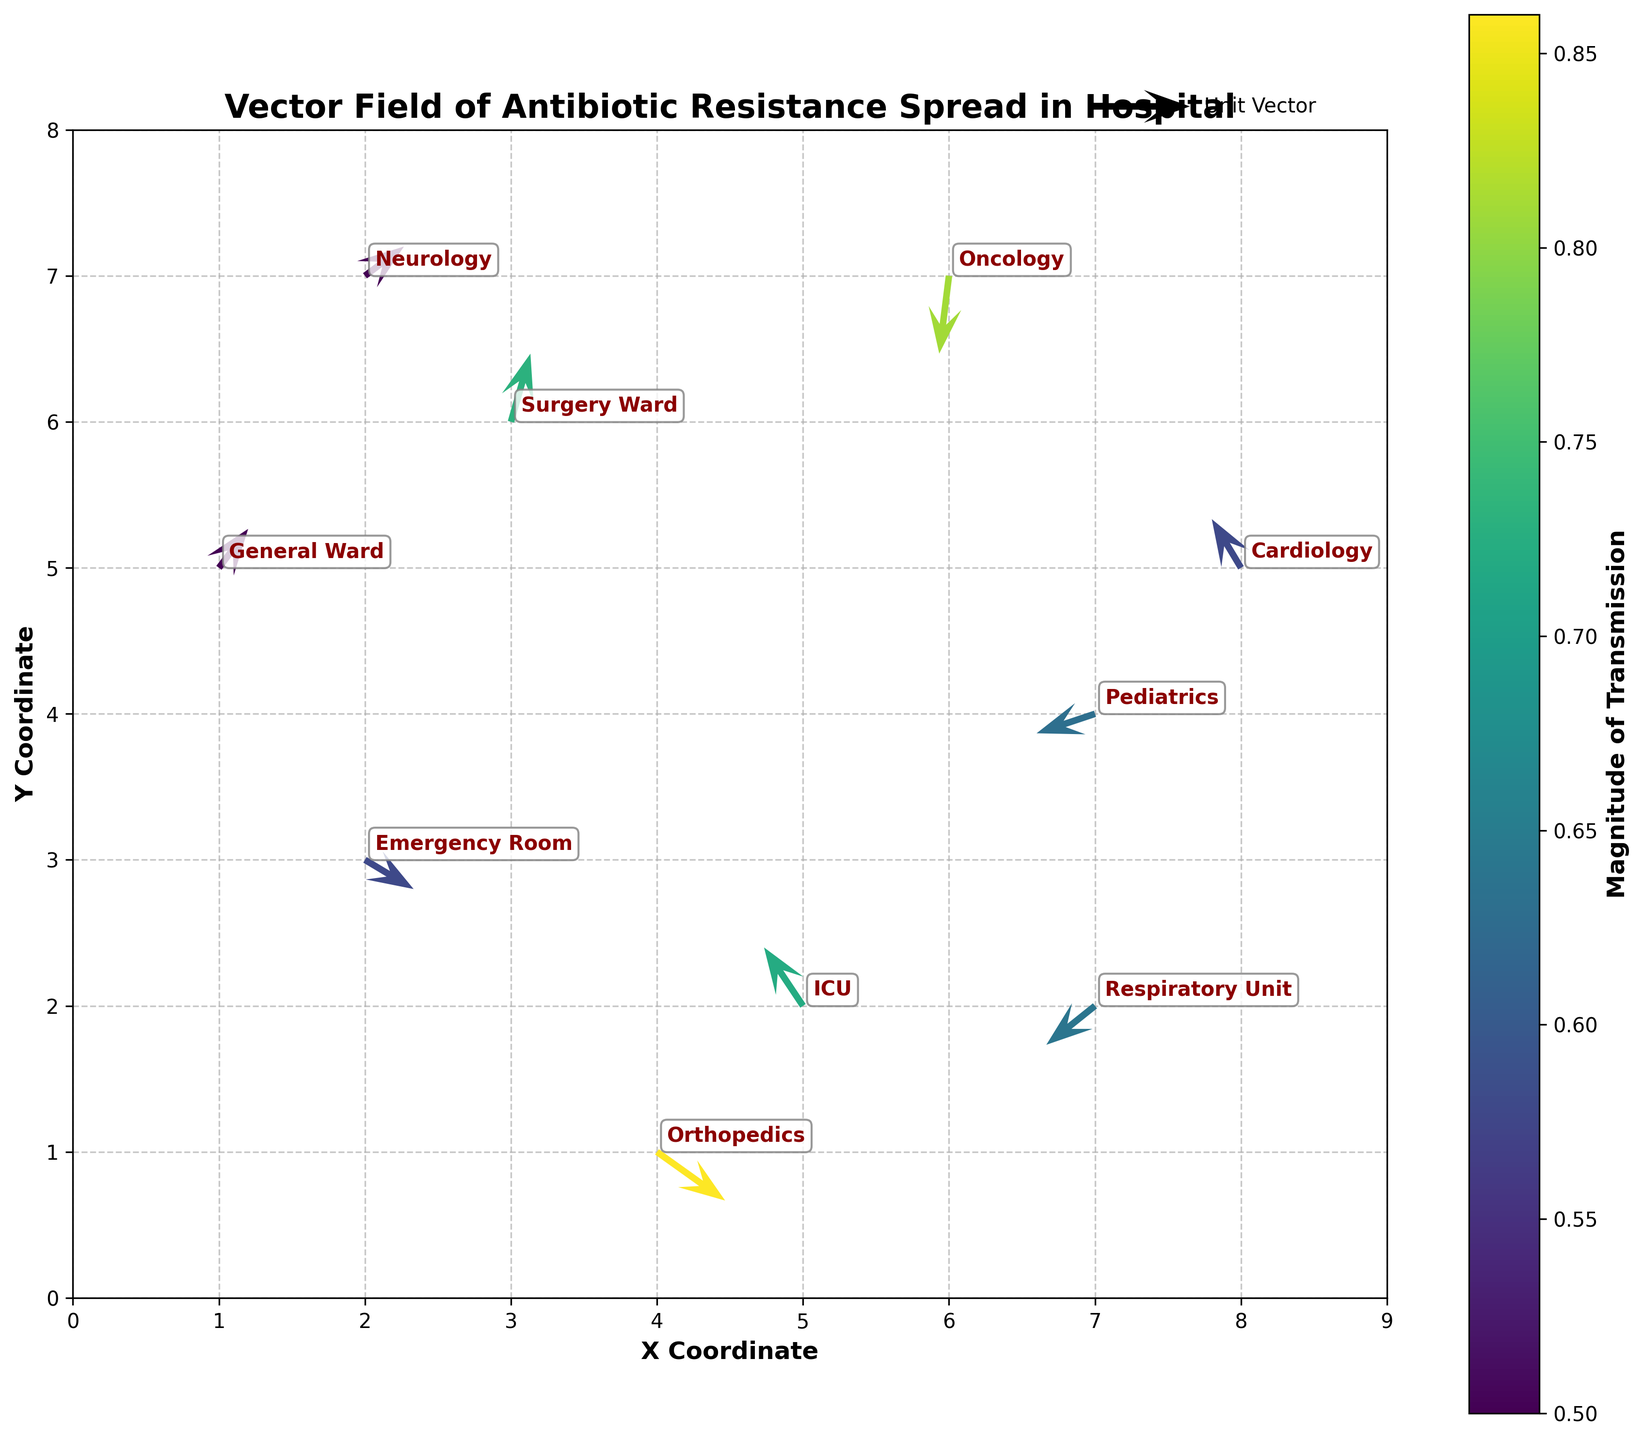What is the title of the figure? The title is usually displayed at the top of the figure. In this case, the title is "Vector Field of Antibiotic Resistance Spread in Hospital."
Answer: Vector Field of Antibiotic Resistance Spread in Hospital How many data points are represented in the figure? We can count the number of arrows or vectors in the quiver plot. Each arrow represents a data point. In this instance, there are 10 data points.
Answer: 10 Which location has the highest magnitude of transmission? We need to identify the vector with the largest magnitude value. According to the data, Oncology has the highest magnitude with a value of 0.81.
Answer: Oncology What are the coordinates of the Surgery Ward? To find this, locate the position of the Surgery Ward from the annotation labels. The coordinates from the data provided are (3, 6).
Answer: (3, 6) Which ward has the transmission vector pointing southwest (negative x and negative y direction)? We need to look for a vector with both negative x and y components (u and v). The Pediatrics ward has a vector of (-0.6, -0.2), pointing southwest.
Answer: Pediatrics Which wards have a smaller or equal magnitude of transmission compared to the General Ward? The General Ward has a magnitude of 0.5. Compare each ward's magnitude to this value. The General Ward, Cardiology, and Neurology all have a magnitude of 0.5 or less.
Answer: General Ward, Cardiology, Neurology How many wards have vectors with a negative x component? Check the x component (u) for each data point and count how many are negative. The ICU, Pediatrics, Oncology, Cardiology, and Respiratory Unit have negative u values. There are 5 in total.
Answer: 5 Which ward has the longest vector of transmission and what are its coordinates? The longest vector corresponds to the highest magnitude, which is 0.81 in the Oncology unit. The coordinates from the data are (6, 7).
Answer: Oncology, (6, 7) What are the coordinates and vector components (u, v) for the Orthopedics ward? Look for the data corresponding to the Orthopedics ward. The coordinates are (4, 1) and the vector components are (0.7, -0.5).
Answer: (4, 1), (0.7, -0.5) 